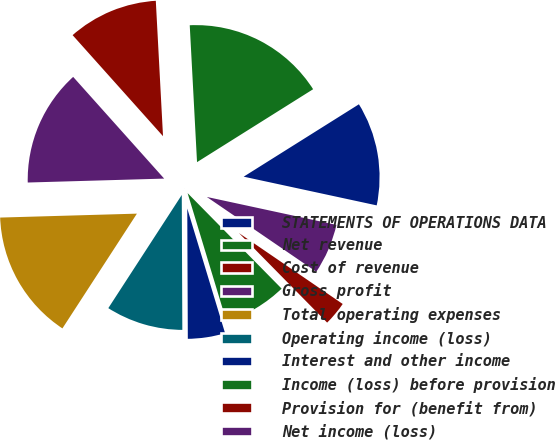Convert chart. <chart><loc_0><loc_0><loc_500><loc_500><pie_chart><fcel>STATEMENTS OF OPERATIONS DATA<fcel>Net revenue<fcel>Cost of revenue<fcel>Gross profit<fcel>Total operating expenses<fcel>Operating income (loss)<fcel>Interest and other income<fcel>Income (loss) before provision<fcel>Provision for (benefit from)<fcel>Net income (loss)<nl><fcel>12.31%<fcel>16.92%<fcel>10.77%<fcel>13.84%<fcel>15.38%<fcel>9.23%<fcel>4.62%<fcel>7.69%<fcel>3.08%<fcel>6.16%<nl></chart> 